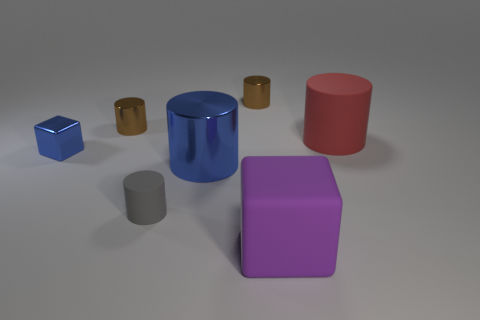Subtract all red cylinders. How many cylinders are left? 4 Subtract all large blue metal cylinders. How many cylinders are left? 4 Subtract all yellow cylinders. Subtract all blue spheres. How many cylinders are left? 5 Add 2 red matte cylinders. How many objects exist? 9 Subtract all cubes. How many objects are left? 5 Add 3 gray rubber cylinders. How many gray rubber cylinders exist? 4 Subtract 0 gray blocks. How many objects are left? 7 Subtract all small yellow shiny cylinders. Subtract all tiny rubber things. How many objects are left? 6 Add 6 red rubber cylinders. How many red rubber cylinders are left? 7 